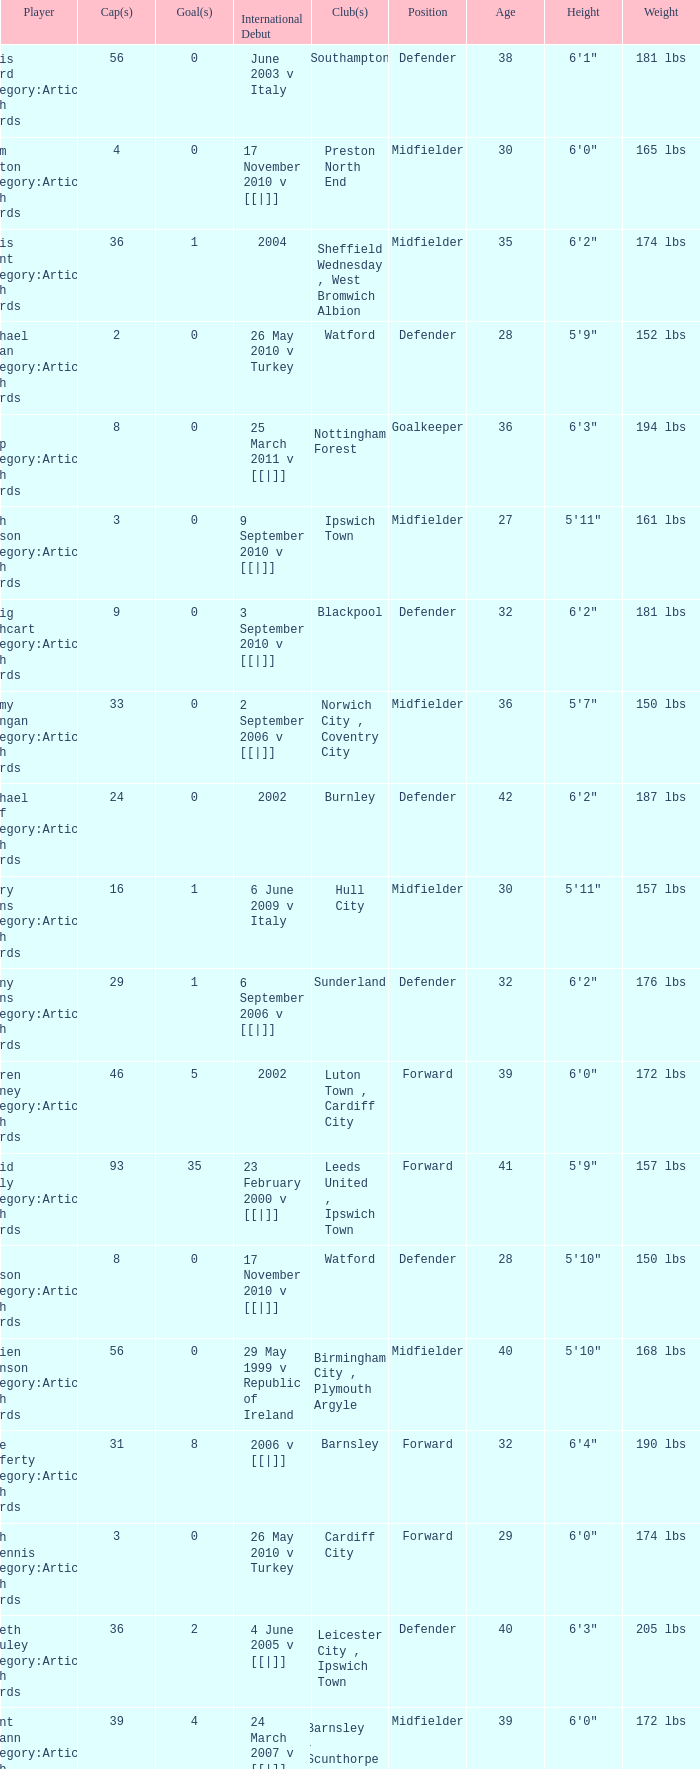How many players had 8 goals? 1.0. 